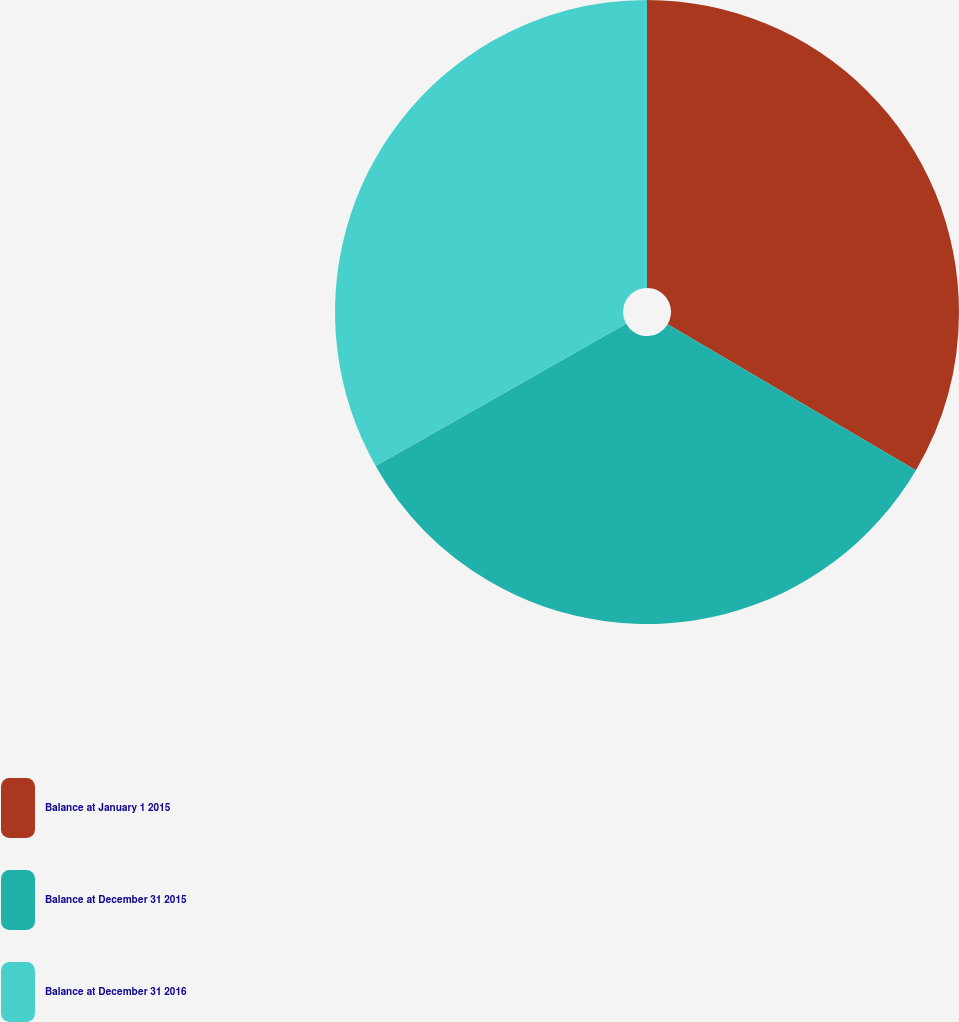<chart> <loc_0><loc_0><loc_500><loc_500><pie_chart><fcel>Balance at January 1 2015<fcel>Balance at December 31 2015<fcel>Balance at December 31 2016<nl><fcel>33.46%<fcel>33.33%<fcel>33.21%<nl></chart> 